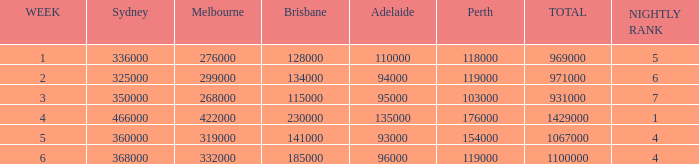What was the total rating on week 3?  931000.0. Could you help me parse every detail presented in this table? {'header': ['WEEK', 'Sydney', 'Melbourne', 'Brisbane', 'Adelaide', 'Perth', 'TOTAL', 'NIGHTLY RANK'], 'rows': [['1', '336000', '276000', '128000', '110000', '118000', '969000', '5'], ['2', '325000', '299000', '134000', '94000', '119000', '971000', '6'], ['3', '350000', '268000', '115000', '95000', '103000', '931000', '7'], ['4', '466000', '422000', '230000', '135000', '176000', '1429000', '1'], ['5', '360000', '319000', '141000', '93000', '154000', '1067000', '4'], ['6', '368000', '332000', '185000', '96000', '119000', '1100000', '4']]} 